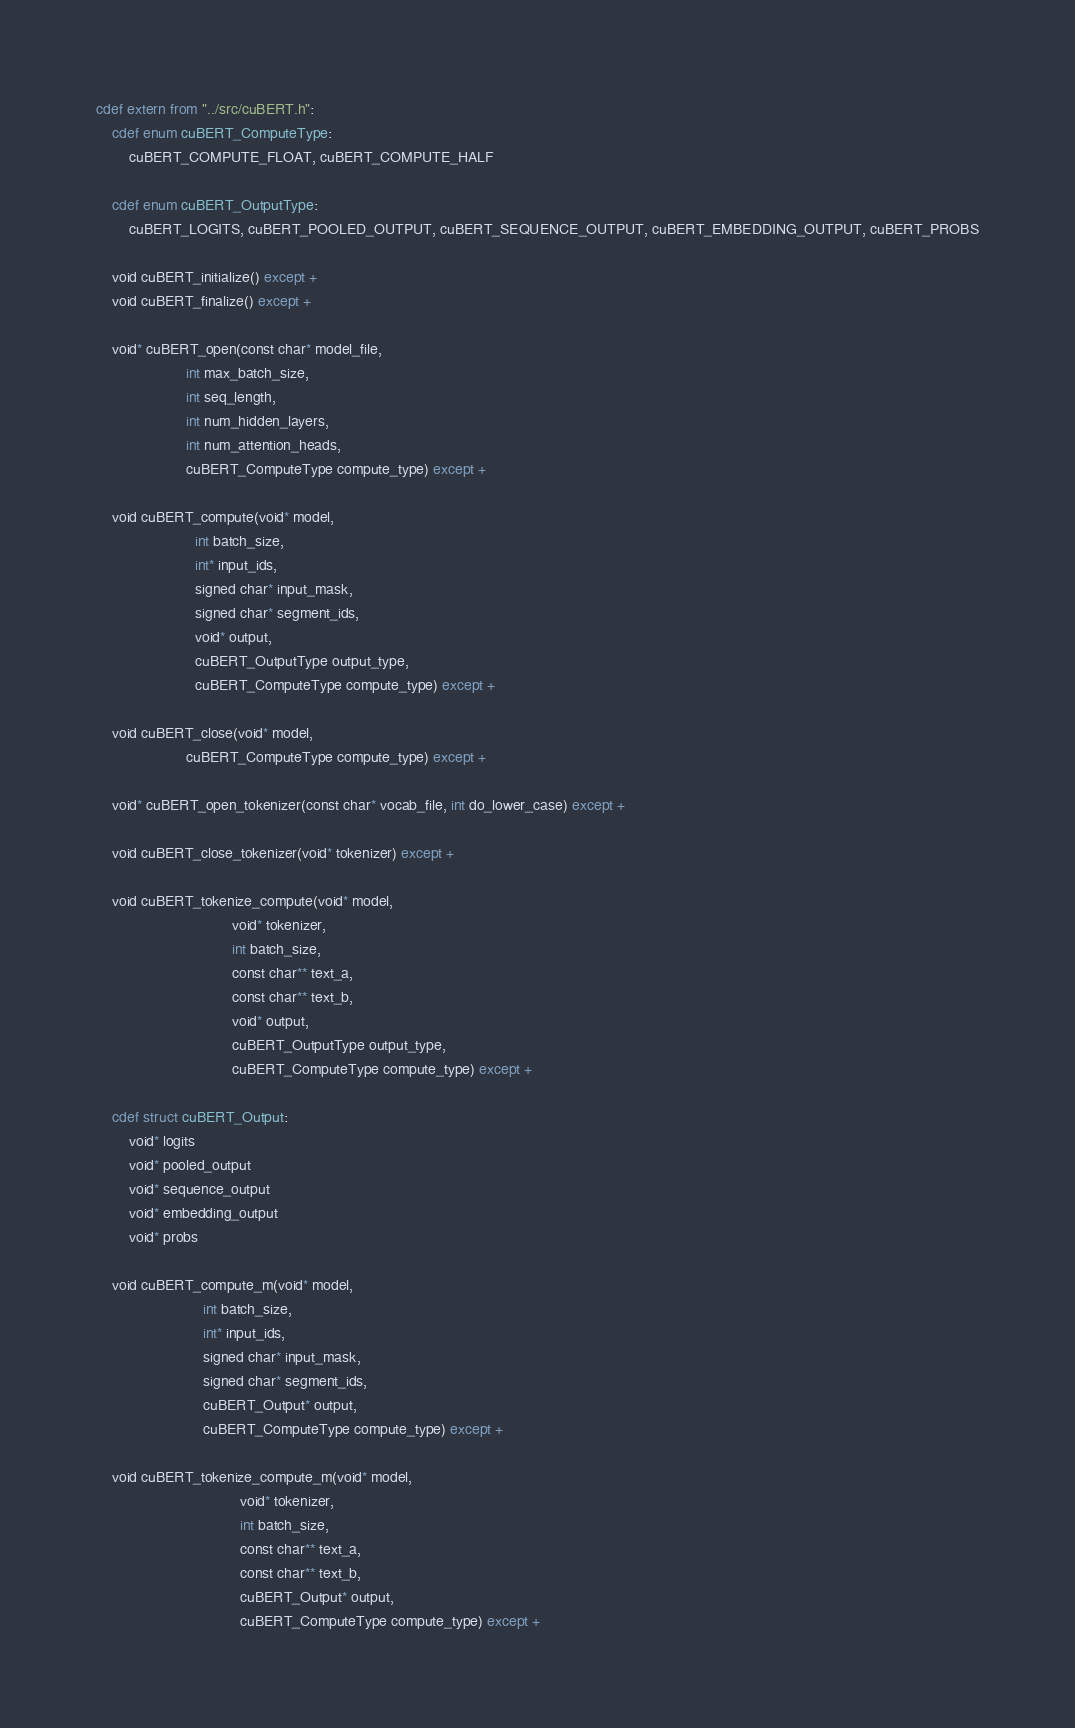Convert code to text. <code><loc_0><loc_0><loc_500><loc_500><_Cython_>cdef extern from "../src/cuBERT.h":
    cdef enum cuBERT_ComputeType:
        cuBERT_COMPUTE_FLOAT, cuBERT_COMPUTE_HALF
    
    cdef enum cuBERT_OutputType:
        cuBERT_LOGITS, cuBERT_POOLED_OUTPUT, cuBERT_SEQUENCE_OUTPUT, cuBERT_EMBEDDING_OUTPUT, cuBERT_PROBS

    void cuBERT_initialize() except +
    void cuBERT_finalize() except +

    void* cuBERT_open(const char* model_file,
                      int max_batch_size,
                      int seq_length,
                      int num_hidden_layers,
                      int num_attention_heads,
                      cuBERT_ComputeType compute_type) except +

    void cuBERT_compute(void* model,
                        int batch_size,
                        int* input_ids,
                        signed char* input_mask,
                        signed char* segment_ids,
                        void* output,
                        cuBERT_OutputType output_type,
                        cuBERT_ComputeType compute_type) except +

    void cuBERT_close(void* model,
                      cuBERT_ComputeType compute_type) except +

    void* cuBERT_open_tokenizer(const char* vocab_file, int do_lower_case) except +

    void cuBERT_close_tokenizer(void* tokenizer) except +

    void cuBERT_tokenize_compute(void* model,
                                 void* tokenizer,
                                 int batch_size,
                                 const char** text_a,
                                 const char** text_b,
                                 void* output,
                                 cuBERT_OutputType output_type,
                                 cuBERT_ComputeType compute_type) except +
    
    cdef struct cuBERT_Output:
        void* logits
        void* pooled_output
        void* sequence_output
        void* embedding_output
        void* probs
    
    void cuBERT_compute_m(void* model,
                          int batch_size,
                          int* input_ids,
                          signed char* input_mask,
                          signed char* segment_ids,
                          cuBERT_Output* output,
                          cuBERT_ComputeType compute_type) except +

    void cuBERT_tokenize_compute_m(void* model,
                                   void* tokenizer,
                                   int batch_size,
                                   const char** text_a,
                                   const char** text_b,
                                   cuBERT_Output* output,
                                   cuBERT_ComputeType compute_type) except +
</code> 